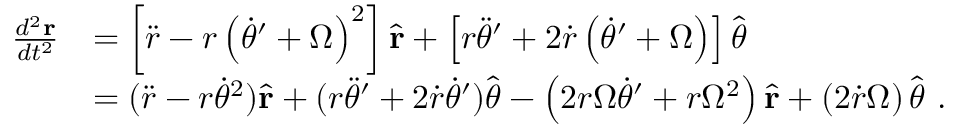<formula> <loc_0><loc_0><loc_500><loc_500>{ \begin{array} { r l } { { \frac { d ^ { 2 } r } { d t ^ { 2 } } } } & { = \left [ { \ddot { r } } - r \left ( { \dot { \theta } } ^ { \prime } + \Omega \right ) ^ { 2 } \right ] { \hat { r } } + \left [ r { \ddot { \theta } } ^ { \prime } + 2 { \dot { r } } \left ( { \dot { \theta } } ^ { \prime } + \Omega \right ) \right ] { \hat { \theta } } } \\ & { = ( { \ddot { r } } - r { \dot { \theta } } ^ { 2 } ) { \hat { r } } + ( r { \ddot { \theta } } ^ { \prime } + 2 { \dot { r } } { \dot { \theta } } ^ { \prime } ) { \hat { \theta } } - \left ( 2 r \Omega { \dot { \theta } } ^ { \prime } + r \Omega ^ { 2 } \right ) { \hat { r } } + \left ( 2 { \dot { r } } \Omega \right ) { \hat { \theta } } \ . } \end{array} }</formula> 